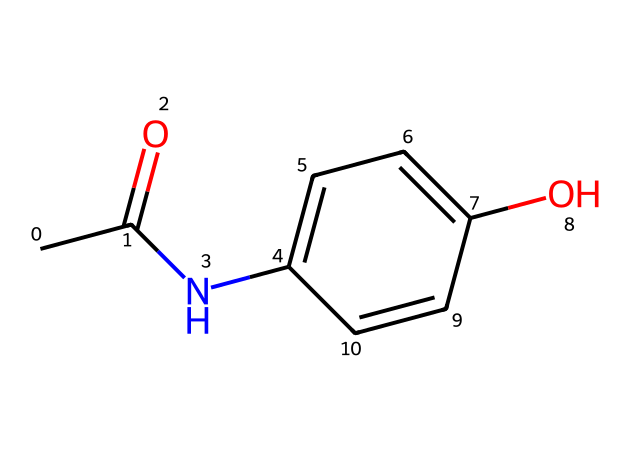What is the molecular formula of the compound? The molecular formula can be determined by counting the number of different types of atoms in the SMILES representation. In this case, there are 8 carbon (C), 9 hydrogen (H), 1 nitrogen (N), and 2 oxygen (O) atoms. Thus, the molecular formula is C8H9NO2.
Answer: C8H9NO2 How many rings are present in the structure? Analyzing the SMILES notation, the 'c' letters indicate aromatic carbon atoms that form a ring system. There is one aromatic ring in the structure, leading to the conclusion that there is one ring present.
Answer: 1 Which functional groups are present? By examining the SMILES representation, we can identify key functional groups. There is an amine (indicated by 'N'), a hydroxy (indicated by 'O' directly bonded to a carbon), and a carbonyl (indicated by 'C(=O)'). Therefore, the functional groups present are amide, hydroxy, and carbonyl.
Answer: amide, hydroxy, carbonyl What type of chemical is this commonly known as? This chemical is commonly identified as a pain reliever, specifically a non-opioid analgesic. Its structure corresponds to acetaminophen, which is widely known for its pain-relieving and fever-reducing effects.
Answer: analgesic What type of bonding is predominant in this molecule? The molecule contains covalent bonds, which are formed between the carbon, nitrogen, and oxygen atoms as they share electrons. Additionally, hydrogen bonding may occur due to the hydroxyl group, enhancing the molecule's solubility in water. Hence, the predominant bonding type is covalent bonding.
Answer: covalent What is the main use of this chemical? Considering the well-established medicinal properties of this molecule, its primary use is as a pain reliever and antipyretic (fever reducer). This is especially relevant for performers who may require relief from pain and discomfort.
Answer: pain reliever 